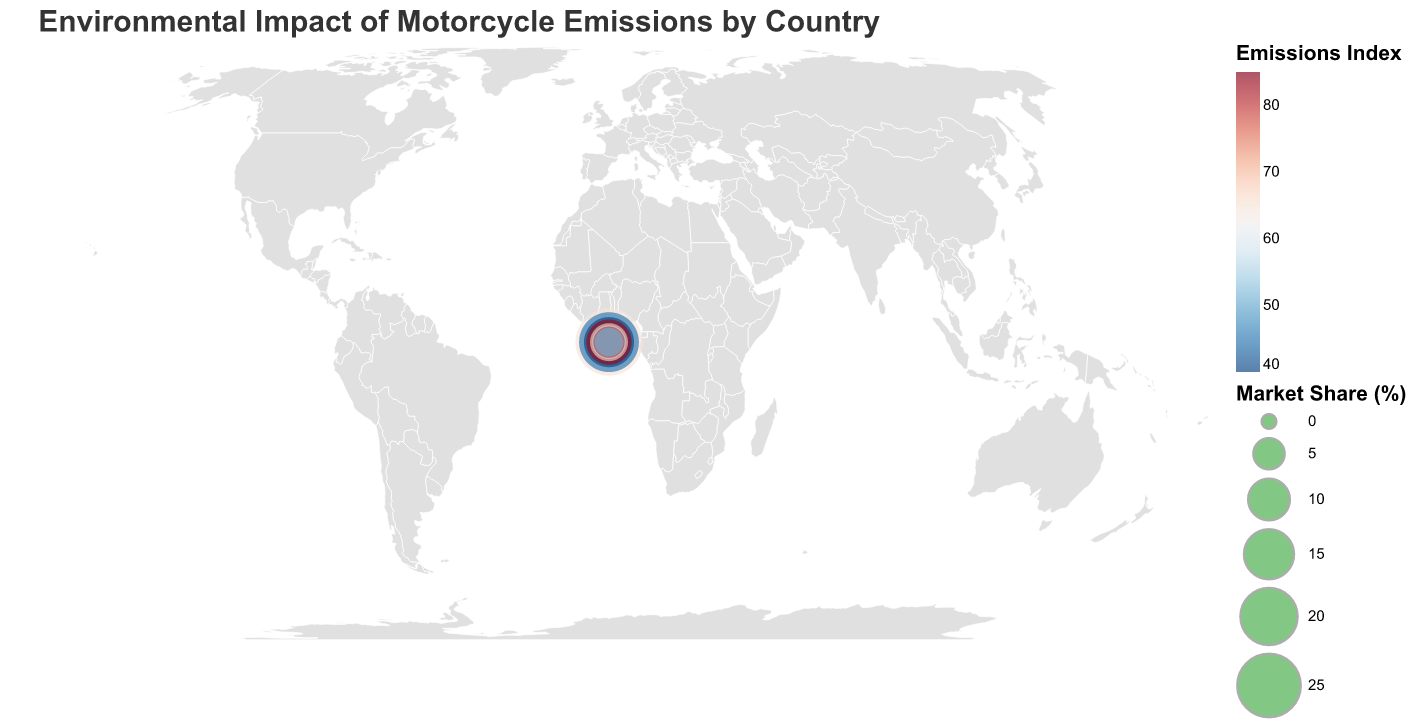What's the title of the figure? The title is displayed at the top of the figure. It is written in a larger font and provides a brief description of the figure.
Answer: Environmental Impact of Motorcycle Emissions by Country How many countries are represented in the dataset? Each country is marked on the figure with a circle. We can count these circles to find the number of countries.
Answer: 8 Which country has the highest Emissions Index? By looking at the color gradient, which corresponds to the Emissions Index, the country with the darkest color has the highest Emissions Index.
Answer: India Which country has the largest market share? Market share is represented by the size of the circles. The country with the largest circle has the largest market share.
Answer: United States What is the Emissions Index of Germany? Locate the circle representing Germany and observe the color legend corresponding to its color, or hover over the circle to see the tooltip.
Answer: 40 Compare the Emissions Index of China and Japan. Which country has a higher value? Locate the circles for China and Japan, compare their colors, and refer to the color legend or the tooltips if necessary.
Answer: China What is the average Emissions Index of European countries represented? Identify the European countries (Germany, Italy, United Kingdom), sum their Emissions Indices (40 + 55 + 50), and calculate the average.
Answer: 48.33 Which region has the highest average Emissions Index? Calculate the average Emissions Index for the countries in each region and compare these averages. For example, for North America (United States), Asia (Japan), Europe (Germany, Italy, United Kingdom), South Asia (India), South America (Brazil), and East Asia (China).
Answer: South Asia Are there any countries with both high market share and low emissions? Check countries with larger circles and lighter colors. The United States has a high market share (largest circle) and a mid-range Emissions Index.
Answer: United States What public relation focus does Brazil emphasize? Hover over or refer to the tooltip information for Brazil to find the PR_Focus.
Answer: Biofuel initiatives 